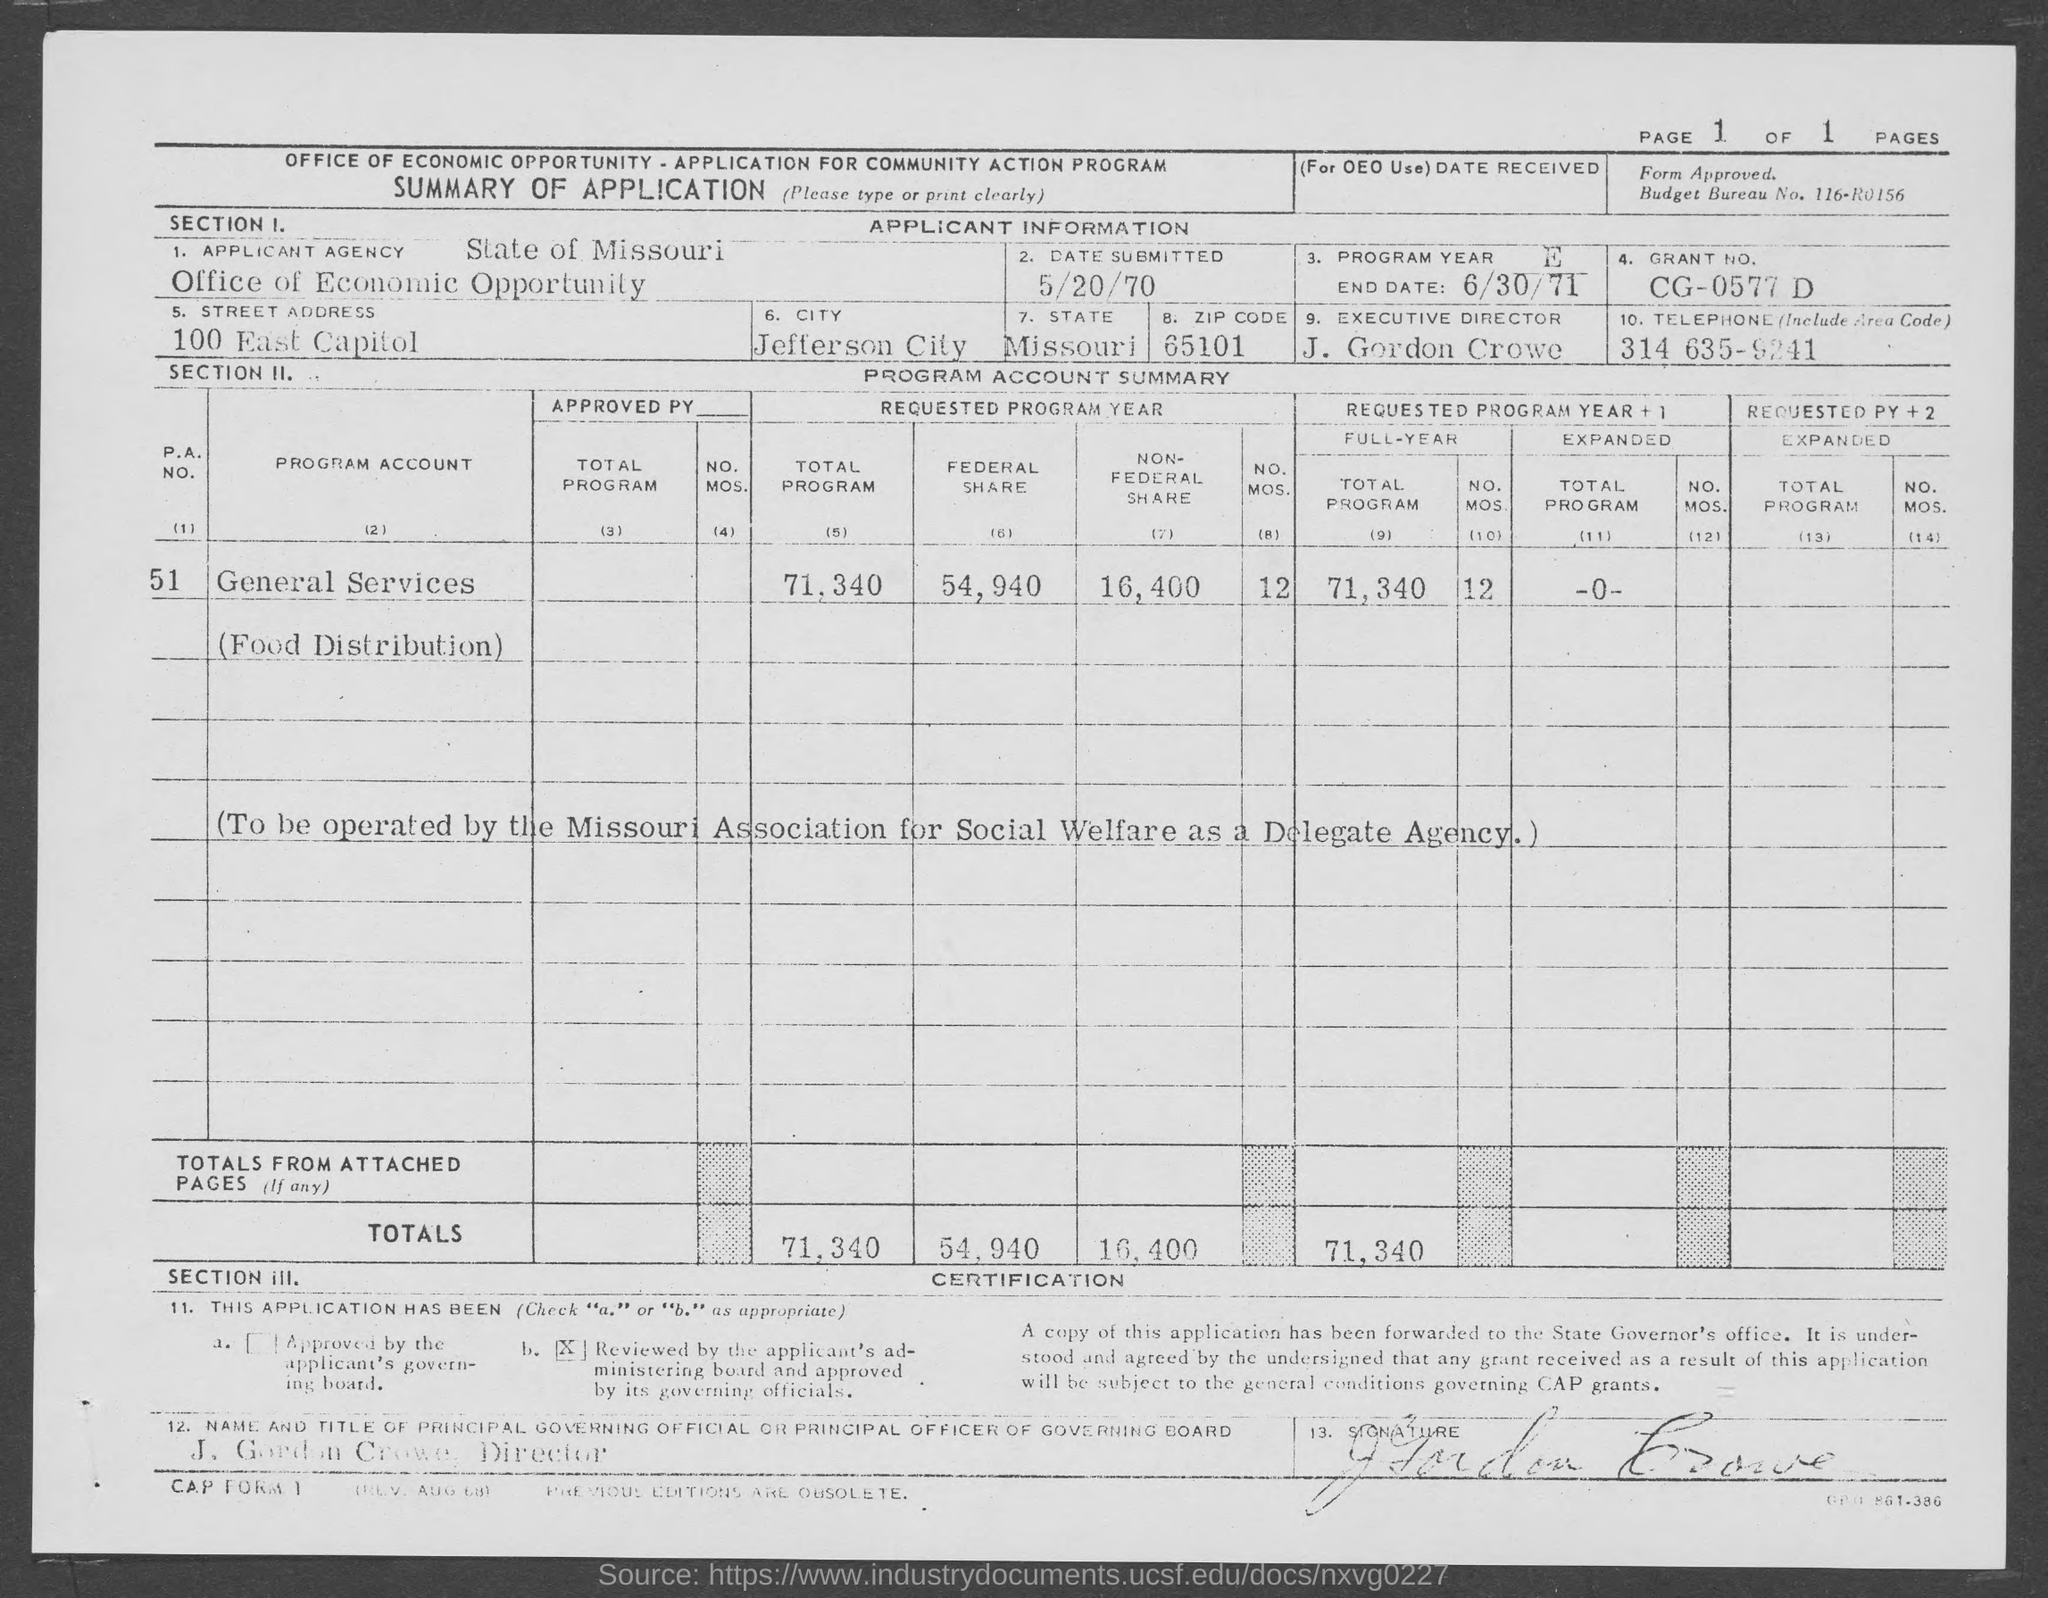Give some essential details in this illustration. The name of the 'APPLICANT AGENCY' office of economic opportunity is The given telephone number is 314-635-9241. The state mentioned in the table is Missouri. What is the GRANT NO. as per the Table? It is CG-0577 D.. The table mentions a city referred to as 'City,' and its name is Jefferson City. 